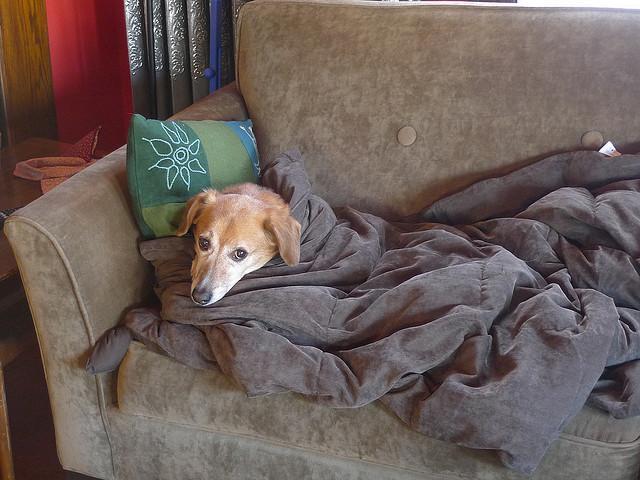How many people are wearing white shirts?
Give a very brief answer. 0. 